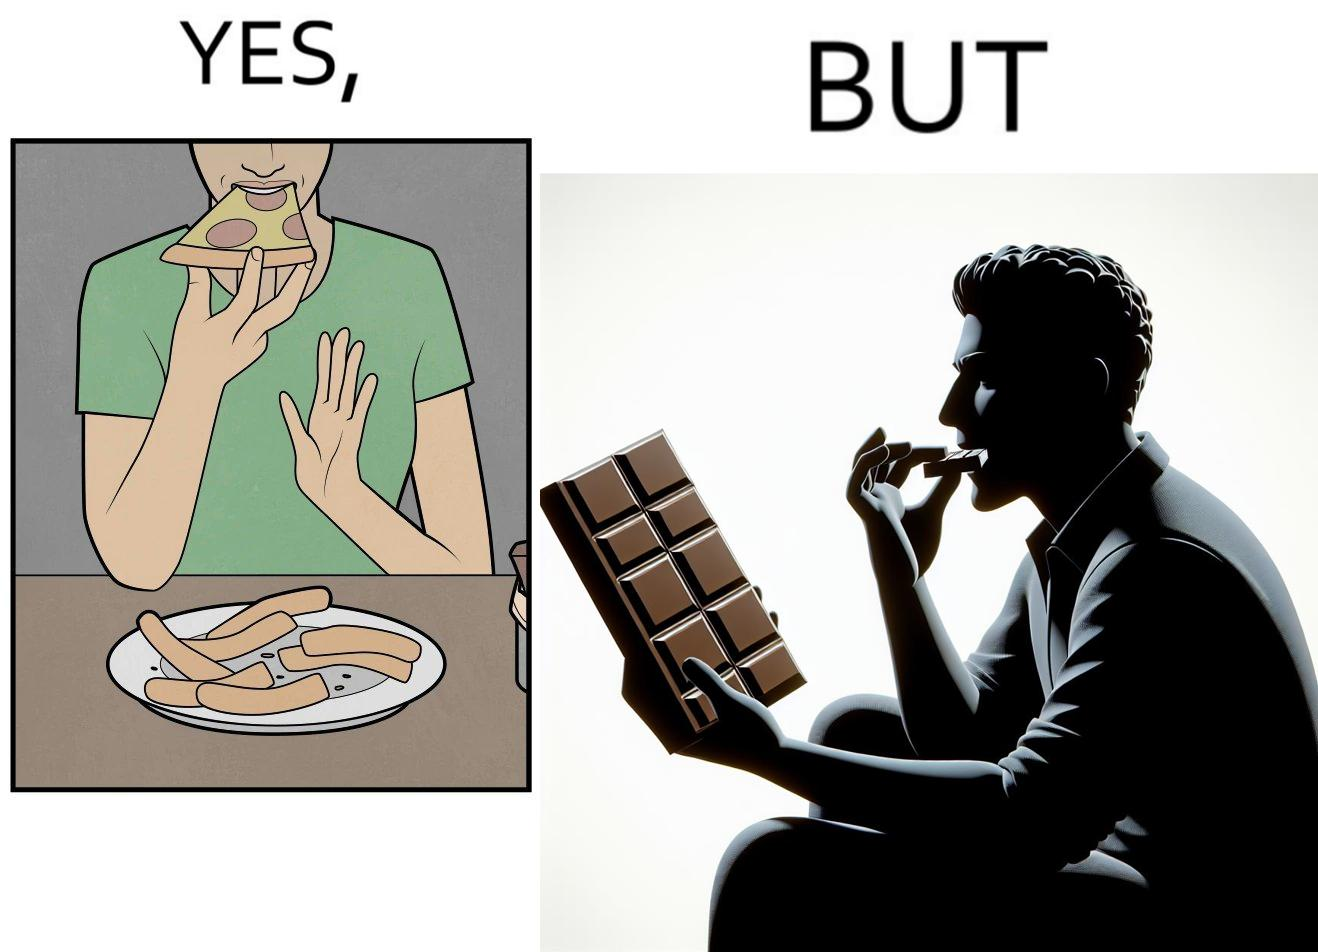Is this image satirical or non-satirical? Yes, this image is satirical. 